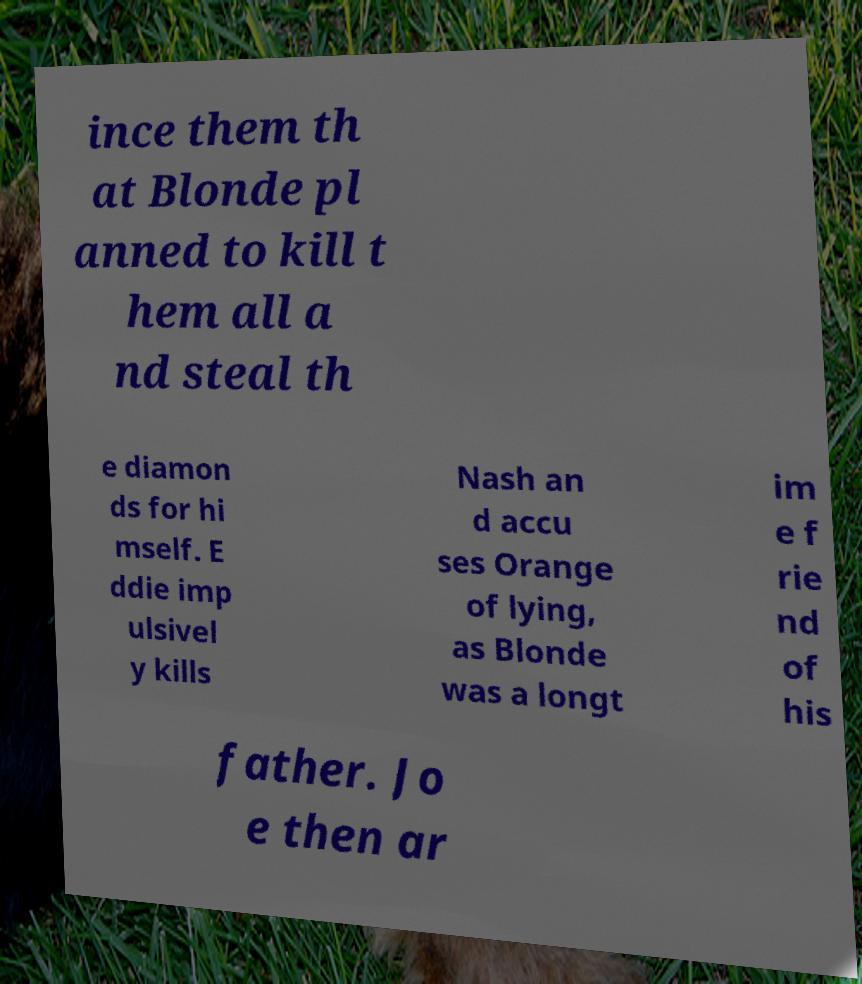For documentation purposes, I need the text within this image transcribed. Could you provide that? ince them th at Blonde pl anned to kill t hem all a nd steal th e diamon ds for hi mself. E ddie imp ulsivel y kills Nash an d accu ses Orange of lying, as Blonde was a longt im e f rie nd of his father. Jo e then ar 